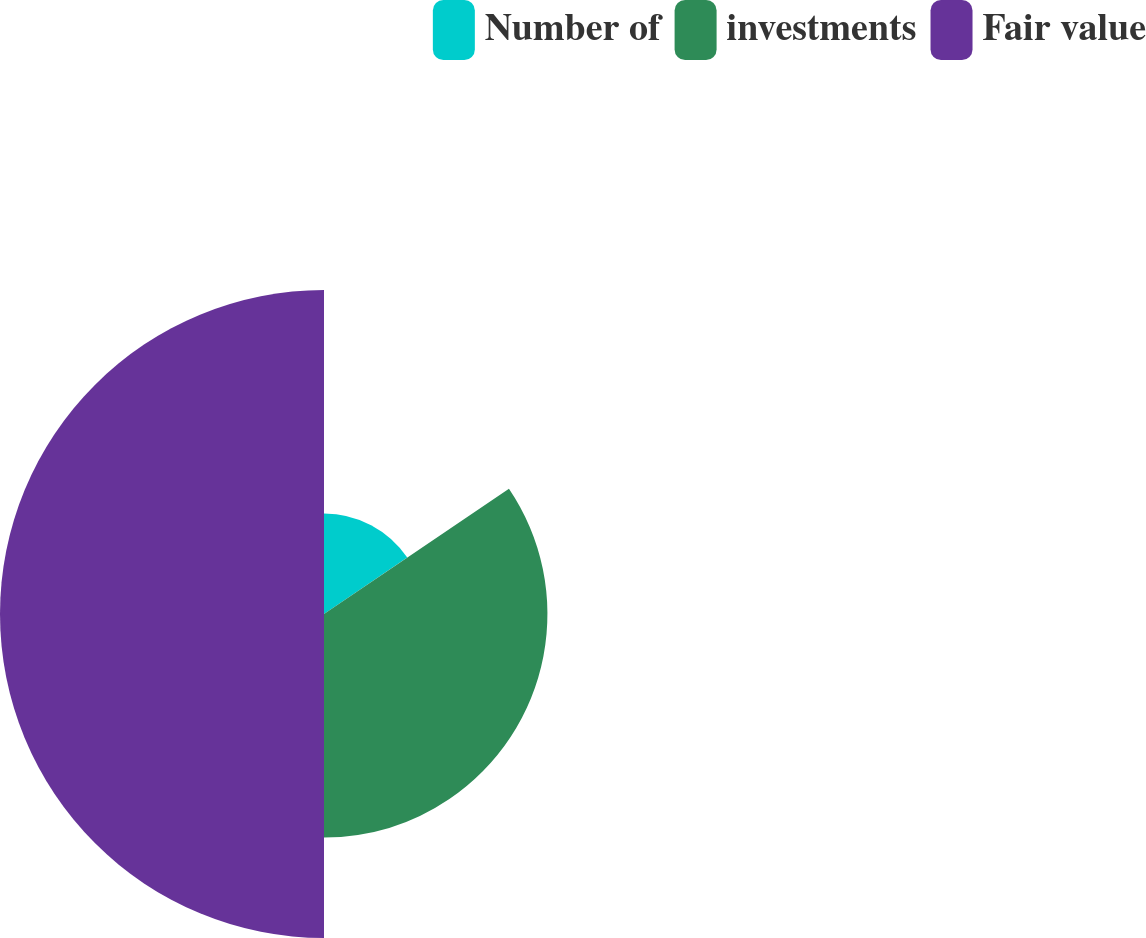Convert chart. <chart><loc_0><loc_0><loc_500><loc_500><pie_chart><fcel>Number of<fcel>investments<fcel>Fair value<nl><fcel>15.52%<fcel>34.48%<fcel>50.0%<nl></chart> 